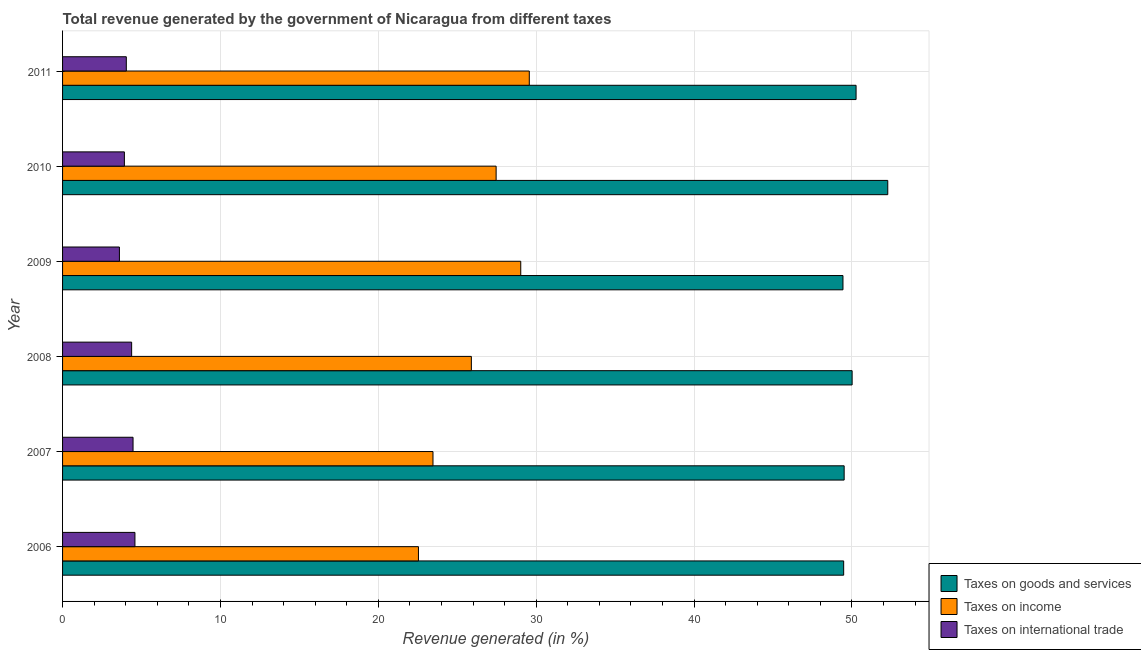How many different coloured bars are there?
Your answer should be very brief. 3. How many groups of bars are there?
Ensure brevity in your answer.  6. Are the number of bars per tick equal to the number of legend labels?
Offer a very short reply. Yes. How many bars are there on the 3rd tick from the top?
Your response must be concise. 3. How many bars are there on the 4th tick from the bottom?
Ensure brevity in your answer.  3. What is the label of the 6th group of bars from the top?
Your answer should be very brief. 2006. In how many cases, is the number of bars for a given year not equal to the number of legend labels?
Give a very brief answer. 0. What is the percentage of revenue generated by taxes on income in 2010?
Keep it short and to the point. 27.46. Across all years, what is the maximum percentage of revenue generated by taxes on goods and services?
Keep it short and to the point. 52.27. Across all years, what is the minimum percentage of revenue generated by taxes on income?
Provide a short and direct response. 22.54. In which year was the percentage of revenue generated by taxes on income maximum?
Offer a terse response. 2011. What is the total percentage of revenue generated by taxes on income in the graph?
Give a very brief answer. 157.94. What is the difference between the percentage of revenue generated by taxes on income in 2008 and that in 2011?
Give a very brief answer. -3.67. What is the difference between the percentage of revenue generated by tax on international trade in 2006 and the percentage of revenue generated by taxes on goods and services in 2008?
Provide a succinct answer. -45.43. What is the average percentage of revenue generated by tax on international trade per year?
Your answer should be very brief. 4.16. In the year 2007, what is the difference between the percentage of revenue generated by taxes on goods and services and percentage of revenue generated by taxes on income?
Provide a short and direct response. 26.04. In how many years, is the percentage of revenue generated by taxes on goods and services greater than 12 %?
Provide a short and direct response. 6. What is the ratio of the percentage of revenue generated by taxes on income in 2008 to that in 2009?
Give a very brief answer. 0.89. What is the difference between the highest and the second highest percentage of revenue generated by tax on international trade?
Keep it short and to the point. 0.12. What is the difference between the highest and the lowest percentage of revenue generated by taxes on income?
Provide a succinct answer. 7.02. In how many years, is the percentage of revenue generated by taxes on income greater than the average percentage of revenue generated by taxes on income taken over all years?
Offer a very short reply. 3. What does the 2nd bar from the top in 2006 represents?
Offer a very short reply. Taxes on income. What does the 1st bar from the bottom in 2009 represents?
Provide a succinct answer. Taxes on goods and services. How many bars are there?
Offer a terse response. 18. Are all the bars in the graph horizontal?
Ensure brevity in your answer.  Yes. Are the values on the major ticks of X-axis written in scientific E-notation?
Keep it short and to the point. No. Does the graph contain any zero values?
Your response must be concise. No. Does the graph contain grids?
Give a very brief answer. Yes. How are the legend labels stacked?
Offer a very short reply. Vertical. What is the title of the graph?
Your answer should be very brief. Total revenue generated by the government of Nicaragua from different taxes. Does "Services" appear as one of the legend labels in the graph?
Provide a short and direct response. No. What is the label or title of the X-axis?
Keep it short and to the point. Revenue generated (in %). What is the label or title of the Y-axis?
Offer a terse response. Year. What is the Revenue generated (in %) in Taxes on goods and services in 2006?
Offer a terse response. 49.47. What is the Revenue generated (in %) in Taxes on income in 2006?
Make the answer very short. 22.54. What is the Revenue generated (in %) in Taxes on international trade in 2006?
Ensure brevity in your answer.  4.58. What is the Revenue generated (in %) in Taxes on goods and services in 2007?
Your answer should be compact. 49.5. What is the Revenue generated (in %) in Taxes on income in 2007?
Give a very brief answer. 23.46. What is the Revenue generated (in %) in Taxes on international trade in 2007?
Make the answer very short. 4.46. What is the Revenue generated (in %) in Taxes on goods and services in 2008?
Provide a short and direct response. 50.01. What is the Revenue generated (in %) of Taxes on income in 2008?
Provide a short and direct response. 25.89. What is the Revenue generated (in %) in Taxes on international trade in 2008?
Your answer should be very brief. 4.38. What is the Revenue generated (in %) of Taxes on goods and services in 2009?
Provide a succinct answer. 49.43. What is the Revenue generated (in %) of Taxes on income in 2009?
Offer a terse response. 29.02. What is the Revenue generated (in %) in Taxes on international trade in 2009?
Your response must be concise. 3.6. What is the Revenue generated (in %) in Taxes on goods and services in 2010?
Offer a terse response. 52.27. What is the Revenue generated (in %) in Taxes on income in 2010?
Provide a short and direct response. 27.46. What is the Revenue generated (in %) in Taxes on international trade in 2010?
Provide a succinct answer. 3.92. What is the Revenue generated (in %) in Taxes on goods and services in 2011?
Offer a terse response. 50.26. What is the Revenue generated (in %) in Taxes on income in 2011?
Offer a very short reply. 29.56. What is the Revenue generated (in %) in Taxes on international trade in 2011?
Offer a very short reply. 4.04. Across all years, what is the maximum Revenue generated (in %) in Taxes on goods and services?
Your response must be concise. 52.27. Across all years, what is the maximum Revenue generated (in %) in Taxes on income?
Make the answer very short. 29.56. Across all years, what is the maximum Revenue generated (in %) in Taxes on international trade?
Your answer should be compact. 4.58. Across all years, what is the minimum Revenue generated (in %) in Taxes on goods and services?
Offer a very short reply. 49.43. Across all years, what is the minimum Revenue generated (in %) in Taxes on income?
Provide a short and direct response. 22.54. Across all years, what is the minimum Revenue generated (in %) in Taxes on international trade?
Keep it short and to the point. 3.6. What is the total Revenue generated (in %) in Taxes on goods and services in the graph?
Provide a succinct answer. 300.95. What is the total Revenue generated (in %) in Taxes on income in the graph?
Offer a very short reply. 157.94. What is the total Revenue generated (in %) in Taxes on international trade in the graph?
Keep it short and to the point. 24.98. What is the difference between the Revenue generated (in %) in Taxes on goods and services in 2006 and that in 2007?
Offer a terse response. -0.03. What is the difference between the Revenue generated (in %) of Taxes on income in 2006 and that in 2007?
Provide a succinct answer. -0.92. What is the difference between the Revenue generated (in %) in Taxes on international trade in 2006 and that in 2007?
Your answer should be very brief. 0.12. What is the difference between the Revenue generated (in %) of Taxes on goods and services in 2006 and that in 2008?
Offer a very short reply. -0.54. What is the difference between the Revenue generated (in %) of Taxes on income in 2006 and that in 2008?
Your response must be concise. -3.35. What is the difference between the Revenue generated (in %) of Taxes on international trade in 2006 and that in 2008?
Offer a terse response. 0.21. What is the difference between the Revenue generated (in %) in Taxes on goods and services in 2006 and that in 2009?
Ensure brevity in your answer.  0.04. What is the difference between the Revenue generated (in %) of Taxes on income in 2006 and that in 2009?
Ensure brevity in your answer.  -6.48. What is the difference between the Revenue generated (in %) in Taxes on international trade in 2006 and that in 2009?
Offer a very short reply. 0.98. What is the difference between the Revenue generated (in %) in Taxes on goods and services in 2006 and that in 2010?
Provide a short and direct response. -2.79. What is the difference between the Revenue generated (in %) in Taxes on income in 2006 and that in 2010?
Keep it short and to the point. -4.92. What is the difference between the Revenue generated (in %) of Taxes on international trade in 2006 and that in 2010?
Your answer should be very brief. 0.67. What is the difference between the Revenue generated (in %) of Taxes on goods and services in 2006 and that in 2011?
Ensure brevity in your answer.  -0.79. What is the difference between the Revenue generated (in %) in Taxes on income in 2006 and that in 2011?
Ensure brevity in your answer.  -7.02. What is the difference between the Revenue generated (in %) of Taxes on international trade in 2006 and that in 2011?
Offer a very short reply. 0.55. What is the difference between the Revenue generated (in %) of Taxes on goods and services in 2007 and that in 2008?
Ensure brevity in your answer.  -0.51. What is the difference between the Revenue generated (in %) of Taxes on income in 2007 and that in 2008?
Your response must be concise. -2.43. What is the difference between the Revenue generated (in %) of Taxes on international trade in 2007 and that in 2008?
Give a very brief answer. 0.09. What is the difference between the Revenue generated (in %) of Taxes on goods and services in 2007 and that in 2009?
Provide a succinct answer. 0.07. What is the difference between the Revenue generated (in %) in Taxes on income in 2007 and that in 2009?
Your response must be concise. -5.56. What is the difference between the Revenue generated (in %) of Taxes on international trade in 2007 and that in 2009?
Keep it short and to the point. 0.86. What is the difference between the Revenue generated (in %) of Taxes on goods and services in 2007 and that in 2010?
Your response must be concise. -2.76. What is the difference between the Revenue generated (in %) in Taxes on income in 2007 and that in 2010?
Your answer should be compact. -4. What is the difference between the Revenue generated (in %) in Taxes on international trade in 2007 and that in 2010?
Keep it short and to the point. 0.55. What is the difference between the Revenue generated (in %) of Taxes on goods and services in 2007 and that in 2011?
Keep it short and to the point. -0.76. What is the difference between the Revenue generated (in %) in Taxes on income in 2007 and that in 2011?
Your response must be concise. -6.1. What is the difference between the Revenue generated (in %) of Taxes on international trade in 2007 and that in 2011?
Your answer should be very brief. 0.43. What is the difference between the Revenue generated (in %) of Taxes on goods and services in 2008 and that in 2009?
Offer a very short reply. 0.58. What is the difference between the Revenue generated (in %) in Taxes on income in 2008 and that in 2009?
Give a very brief answer. -3.13. What is the difference between the Revenue generated (in %) of Taxes on international trade in 2008 and that in 2009?
Your answer should be compact. 0.77. What is the difference between the Revenue generated (in %) in Taxes on goods and services in 2008 and that in 2010?
Your answer should be compact. -2.26. What is the difference between the Revenue generated (in %) in Taxes on income in 2008 and that in 2010?
Your response must be concise. -1.57. What is the difference between the Revenue generated (in %) of Taxes on international trade in 2008 and that in 2010?
Give a very brief answer. 0.46. What is the difference between the Revenue generated (in %) of Taxes on income in 2008 and that in 2011?
Offer a terse response. -3.67. What is the difference between the Revenue generated (in %) of Taxes on international trade in 2008 and that in 2011?
Offer a terse response. 0.34. What is the difference between the Revenue generated (in %) in Taxes on goods and services in 2009 and that in 2010?
Your answer should be compact. -2.84. What is the difference between the Revenue generated (in %) of Taxes on income in 2009 and that in 2010?
Provide a short and direct response. 1.56. What is the difference between the Revenue generated (in %) in Taxes on international trade in 2009 and that in 2010?
Ensure brevity in your answer.  -0.31. What is the difference between the Revenue generated (in %) of Taxes on goods and services in 2009 and that in 2011?
Offer a very short reply. -0.83. What is the difference between the Revenue generated (in %) in Taxes on income in 2009 and that in 2011?
Provide a short and direct response. -0.54. What is the difference between the Revenue generated (in %) of Taxes on international trade in 2009 and that in 2011?
Your answer should be compact. -0.44. What is the difference between the Revenue generated (in %) in Taxes on goods and services in 2010 and that in 2011?
Provide a short and direct response. 2.01. What is the difference between the Revenue generated (in %) in Taxes on income in 2010 and that in 2011?
Your response must be concise. -2.1. What is the difference between the Revenue generated (in %) in Taxes on international trade in 2010 and that in 2011?
Offer a very short reply. -0.12. What is the difference between the Revenue generated (in %) of Taxes on goods and services in 2006 and the Revenue generated (in %) of Taxes on income in 2007?
Provide a short and direct response. 26.01. What is the difference between the Revenue generated (in %) of Taxes on goods and services in 2006 and the Revenue generated (in %) of Taxes on international trade in 2007?
Give a very brief answer. 45.01. What is the difference between the Revenue generated (in %) of Taxes on income in 2006 and the Revenue generated (in %) of Taxes on international trade in 2007?
Your response must be concise. 18.08. What is the difference between the Revenue generated (in %) in Taxes on goods and services in 2006 and the Revenue generated (in %) in Taxes on income in 2008?
Your answer should be very brief. 23.58. What is the difference between the Revenue generated (in %) in Taxes on goods and services in 2006 and the Revenue generated (in %) in Taxes on international trade in 2008?
Provide a short and direct response. 45.1. What is the difference between the Revenue generated (in %) of Taxes on income in 2006 and the Revenue generated (in %) of Taxes on international trade in 2008?
Offer a very short reply. 18.17. What is the difference between the Revenue generated (in %) of Taxes on goods and services in 2006 and the Revenue generated (in %) of Taxes on income in 2009?
Provide a short and direct response. 20.45. What is the difference between the Revenue generated (in %) of Taxes on goods and services in 2006 and the Revenue generated (in %) of Taxes on international trade in 2009?
Your answer should be compact. 45.87. What is the difference between the Revenue generated (in %) in Taxes on income in 2006 and the Revenue generated (in %) in Taxes on international trade in 2009?
Ensure brevity in your answer.  18.94. What is the difference between the Revenue generated (in %) of Taxes on goods and services in 2006 and the Revenue generated (in %) of Taxes on income in 2010?
Offer a very short reply. 22.01. What is the difference between the Revenue generated (in %) in Taxes on goods and services in 2006 and the Revenue generated (in %) in Taxes on international trade in 2010?
Your answer should be very brief. 45.56. What is the difference between the Revenue generated (in %) of Taxes on income in 2006 and the Revenue generated (in %) of Taxes on international trade in 2010?
Your response must be concise. 18.63. What is the difference between the Revenue generated (in %) in Taxes on goods and services in 2006 and the Revenue generated (in %) in Taxes on income in 2011?
Keep it short and to the point. 19.91. What is the difference between the Revenue generated (in %) of Taxes on goods and services in 2006 and the Revenue generated (in %) of Taxes on international trade in 2011?
Give a very brief answer. 45.44. What is the difference between the Revenue generated (in %) in Taxes on income in 2006 and the Revenue generated (in %) in Taxes on international trade in 2011?
Offer a terse response. 18.5. What is the difference between the Revenue generated (in %) of Taxes on goods and services in 2007 and the Revenue generated (in %) of Taxes on income in 2008?
Offer a very short reply. 23.61. What is the difference between the Revenue generated (in %) in Taxes on goods and services in 2007 and the Revenue generated (in %) in Taxes on international trade in 2008?
Give a very brief answer. 45.13. What is the difference between the Revenue generated (in %) in Taxes on income in 2007 and the Revenue generated (in %) in Taxes on international trade in 2008?
Provide a short and direct response. 19.09. What is the difference between the Revenue generated (in %) of Taxes on goods and services in 2007 and the Revenue generated (in %) of Taxes on income in 2009?
Your answer should be very brief. 20.48. What is the difference between the Revenue generated (in %) in Taxes on goods and services in 2007 and the Revenue generated (in %) in Taxes on international trade in 2009?
Give a very brief answer. 45.9. What is the difference between the Revenue generated (in %) in Taxes on income in 2007 and the Revenue generated (in %) in Taxes on international trade in 2009?
Make the answer very short. 19.86. What is the difference between the Revenue generated (in %) of Taxes on goods and services in 2007 and the Revenue generated (in %) of Taxes on income in 2010?
Keep it short and to the point. 22.04. What is the difference between the Revenue generated (in %) of Taxes on goods and services in 2007 and the Revenue generated (in %) of Taxes on international trade in 2010?
Your response must be concise. 45.59. What is the difference between the Revenue generated (in %) in Taxes on income in 2007 and the Revenue generated (in %) in Taxes on international trade in 2010?
Give a very brief answer. 19.55. What is the difference between the Revenue generated (in %) in Taxes on goods and services in 2007 and the Revenue generated (in %) in Taxes on income in 2011?
Keep it short and to the point. 19.94. What is the difference between the Revenue generated (in %) of Taxes on goods and services in 2007 and the Revenue generated (in %) of Taxes on international trade in 2011?
Offer a very short reply. 45.47. What is the difference between the Revenue generated (in %) of Taxes on income in 2007 and the Revenue generated (in %) of Taxes on international trade in 2011?
Provide a succinct answer. 19.42. What is the difference between the Revenue generated (in %) of Taxes on goods and services in 2008 and the Revenue generated (in %) of Taxes on income in 2009?
Make the answer very short. 20.99. What is the difference between the Revenue generated (in %) of Taxes on goods and services in 2008 and the Revenue generated (in %) of Taxes on international trade in 2009?
Keep it short and to the point. 46.41. What is the difference between the Revenue generated (in %) of Taxes on income in 2008 and the Revenue generated (in %) of Taxes on international trade in 2009?
Your answer should be very brief. 22.29. What is the difference between the Revenue generated (in %) of Taxes on goods and services in 2008 and the Revenue generated (in %) of Taxes on income in 2010?
Give a very brief answer. 22.55. What is the difference between the Revenue generated (in %) in Taxes on goods and services in 2008 and the Revenue generated (in %) in Taxes on international trade in 2010?
Make the answer very short. 46.09. What is the difference between the Revenue generated (in %) in Taxes on income in 2008 and the Revenue generated (in %) in Taxes on international trade in 2010?
Keep it short and to the point. 21.98. What is the difference between the Revenue generated (in %) in Taxes on goods and services in 2008 and the Revenue generated (in %) in Taxes on income in 2011?
Ensure brevity in your answer.  20.45. What is the difference between the Revenue generated (in %) of Taxes on goods and services in 2008 and the Revenue generated (in %) of Taxes on international trade in 2011?
Ensure brevity in your answer.  45.97. What is the difference between the Revenue generated (in %) of Taxes on income in 2008 and the Revenue generated (in %) of Taxes on international trade in 2011?
Make the answer very short. 21.86. What is the difference between the Revenue generated (in %) of Taxes on goods and services in 2009 and the Revenue generated (in %) of Taxes on income in 2010?
Your answer should be very brief. 21.97. What is the difference between the Revenue generated (in %) in Taxes on goods and services in 2009 and the Revenue generated (in %) in Taxes on international trade in 2010?
Provide a short and direct response. 45.51. What is the difference between the Revenue generated (in %) of Taxes on income in 2009 and the Revenue generated (in %) of Taxes on international trade in 2010?
Keep it short and to the point. 25.1. What is the difference between the Revenue generated (in %) in Taxes on goods and services in 2009 and the Revenue generated (in %) in Taxes on income in 2011?
Ensure brevity in your answer.  19.87. What is the difference between the Revenue generated (in %) in Taxes on goods and services in 2009 and the Revenue generated (in %) in Taxes on international trade in 2011?
Give a very brief answer. 45.39. What is the difference between the Revenue generated (in %) in Taxes on income in 2009 and the Revenue generated (in %) in Taxes on international trade in 2011?
Your response must be concise. 24.98. What is the difference between the Revenue generated (in %) of Taxes on goods and services in 2010 and the Revenue generated (in %) of Taxes on income in 2011?
Offer a terse response. 22.7. What is the difference between the Revenue generated (in %) in Taxes on goods and services in 2010 and the Revenue generated (in %) in Taxes on international trade in 2011?
Provide a short and direct response. 48.23. What is the difference between the Revenue generated (in %) of Taxes on income in 2010 and the Revenue generated (in %) of Taxes on international trade in 2011?
Offer a very short reply. 23.42. What is the average Revenue generated (in %) of Taxes on goods and services per year?
Provide a short and direct response. 50.16. What is the average Revenue generated (in %) in Taxes on income per year?
Your answer should be very brief. 26.32. What is the average Revenue generated (in %) in Taxes on international trade per year?
Ensure brevity in your answer.  4.16. In the year 2006, what is the difference between the Revenue generated (in %) in Taxes on goods and services and Revenue generated (in %) in Taxes on income?
Ensure brevity in your answer.  26.93. In the year 2006, what is the difference between the Revenue generated (in %) of Taxes on goods and services and Revenue generated (in %) of Taxes on international trade?
Provide a succinct answer. 44.89. In the year 2006, what is the difference between the Revenue generated (in %) in Taxes on income and Revenue generated (in %) in Taxes on international trade?
Your response must be concise. 17.96. In the year 2007, what is the difference between the Revenue generated (in %) of Taxes on goods and services and Revenue generated (in %) of Taxes on income?
Your answer should be compact. 26.04. In the year 2007, what is the difference between the Revenue generated (in %) in Taxes on goods and services and Revenue generated (in %) in Taxes on international trade?
Provide a short and direct response. 45.04. In the year 2007, what is the difference between the Revenue generated (in %) in Taxes on income and Revenue generated (in %) in Taxes on international trade?
Give a very brief answer. 19. In the year 2008, what is the difference between the Revenue generated (in %) of Taxes on goods and services and Revenue generated (in %) of Taxes on income?
Offer a terse response. 24.12. In the year 2008, what is the difference between the Revenue generated (in %) of Taxes on goods and services and Revenue generated (in %) of Taxes on international trade?
Provide a succinct answer. 45.63. In the year 2008, what is the difference between the Revenue generated (in %) of Taxes on income and Revenue generated (in %) of Taxes on international trade?
Make the answer very short. 21.52. In the year 2009, what is the difference between the Revenue generated (in %) of Taxes on goods and services and Revenue generated (in %) of Taxes on income?
Your response must be concise. 20.41. In the year 2009, what is the difference between the Revenue generated (in %) in Taxes on goods and services and Revenue generated (in %) in Taxes on international trade?
Your answer should be compact. 45.83. In the year 2009, what is the difference between the Revenue generated (in %) of Taxes on income and Revenue generated (in %) of Taxes on international trade?
Provide a succinct answer. 25.42. In the year 2010, what is the difference between the Revenue generated (in %) of Taxes on goods and services and Revenue generated (in %) of Taxes on income?
Offer a terse response. 24.81. In the year 2010, what is the difference between the Revenue generated (in %) of Taxes on goods and services and Revenue generated (in %) of Taxes on international trade?
Your answer should be very brief. 48.35. In the year 2010, what is the difference between the Revenue generated (in %) of Taxes on income and Revenue generated (in %) of Taxes on international trade?
Provide a succinct answer. 23.55. In the year 2011, what is the difference between the Revenue generated (in %) of Taxes on goods and services and Revenue generated (in %) of Taxes on income?
Provide a succinct answer. 20.7. In the year 2011, what is the difference between the Revenue generated (in %) of Taxes on goods and services and Revenue generated (in %) of Taxes on international trade?
Your answer should be very brief. 46.22. In the year 2011, what is the difference between the Revenue generated (in %) of Taxes on income and Revenue generated (in %) of Taxes on international trade?
Keep it short and to the point. 25.53. What is the ratio of the Revenue generated (in %) in Taxes on income in 2006 to that in 2007?
Offer a terse response. 0.96. What is the ratio of the Revenue generated (in %) of Taxes on international trade in 2006 to that in 2007?
Give a very brief answer. 1.03. What is the ratio of the Revenue generated (in %) in Taxes on goods and services in 2006 to that in 2008?
Provide a succinct answer. 0.99. What is the ratio of the Revenue generated (in %) in Taxes on income in 2006 to that in 2008?
Your answer should be compact. 0.87. What is the ratio of the Revenue generated (in %) of Taxes on international trade in 2006 to that in 2008?
Your response must be concise. 1.05. What is the ratio of the Revenue generated (in %) of Taxes on income in 2006 to that in 2009?
Offer a very short reply. 0.78. What is the ratio of the Revenue generated (in %) in Taxes on international trade in 2006 to that in 2009?
Offer a terse response. 1.27. What is the ratio of the Revenue generated (in %) of Taxes on goods and services in 2006 to that in 2010?
Provide a succinct answer. 0.95. What is the ratio of the Revenue generated (in %) in Taxes on income in 2006 to that in 2010?
Your response must be concise. 0.82. What is the ratio of the Revenue generated (in %) in Taxes on international trade in 2006 to that in 2010?
Your response must be concise. 1.17. What is the ratio of the Revenue generated (in %) of Taxes on goods and services in 2006 to that in 2011?
Give a very brief answer. 0.98. What is the ratio of the Revenue generated (in %) in Taxes on income in 2006 to that in 2011?
Ensure brevity in your answer.  0.76. What is the ratio of the Revenue generated (in %) of Taxes on international trade in 2006 to that in 2011?
Your answer should be compact. 1.14. What is the ratio of the Revenue generated (in %) in Taxes on goods and services in 2007 to that in 2008?
Provide a short and direct response. 0.99. What is the ratio of the Revenue generated (in %) of Taxes on income in 2007 to that in 2008?
Give a very brief answer. 0.91. What is the ratio of the Revenue generated (in %) of Taxes on international trade in 2007 to that in 2008?
Provide a succinct answer. 1.02. What is the ratio of the Revenue generated (in %) in Taxes on goods and services in 2007 to that in 2009?
Offer a terse response. 1. What is the ratio of the Revenue generated (in %) in Taxes on income in 2007 to that in 2009?
Provide a succinct answer. 0.81. What is the ratio of the Revenue generated (in %) of Taxes on international trade in 2007 to that in 2009?
Ensure brevity in your answer.  1.24. What is the ratio of the Revenue generated (in %) in Taxes on goods and services in 2007 to that in 2010?
Offer a terse response. 0.95. What is the ratio of the Revenue generated (in %) of Taxes on income in 2007 to that in 2010?
Make the answer very short. 0.85. What is the ratio of the Revenue generated (in %) in Taxes on international trade in 2007 to that in 2010?
Offer a terse response. 1.14. What is the ratio of the Revenue generated (in %) of Taxes on income in 2007 to that in 2011?
Ensure brevity in your answer.  0.79. What is the ratio of the Revenue generated (in %) of Taxes on international trade in 2007 to that in 2011?
Your response must be concise. 1.11. What is the ratio of the Revenue generated (in %) in Taxes on goods and services in 2008 to that in 2009?
Offer a very short reply. 1.01. What is the ratio of the Revenue generated (in %) of Taxes on income in 2008 to that in 2009?
Your answer should be very brief. 0.89. What is the ratio of the Revenue generated (in %) of Taxes on international trade in 2008 to that in 2009?
Make the answer very short. 1.21. What is the ratio of the Revenue generated (in %) in Taxes on goods and services in 2008 to that in 2010?
Offer a very short reply. 0.96. What is the ratio of the Revenue generated (in %) in Taxes on income in 2008 to that in 2010?
Your answer should be very brief. 0.94. What is the ratio of the Revenue generated (in %) in Taxes on international trade in 2008 to that in 2010?
Your answer should be very brief. 1.12. What is the ratio of the Revenue generated (in %) in Taxes on income in 2008 to that in 2011?
Your answer should be compact. 0.88. What is the ratio of the Revenue generated (in %) of Taxes on international trade in 2008 to that in 2011?
Offer a very short reply. 1.08. What is the ratio of the Revenue generated (in %) of Taxes on goods and services in 2009 to that in 2010?
Offer a terse response. 0.95. What is the ratio of the Revenue generated (in %) of Taxes on income in 2009 to that in 2010?
Provide a short and direct response. 1.06. What is the ratio of the Revenue generated (in %) in Taxes on international trade in 2009 to that in 2010?
Offer a terse response. 0.92. What is the ratio of the Revenue generated (in %) in Taxes on goods and services in 2009 to that in 2011?
Make the answer very short. 0.98. What is the ratio of the Revenue generated (in %) in Taxes on income in 2009 to that in 2011?
Your response must be concise. 0.98. What is the ratio of the Revenue generated (in %) of Taxes on international trade in 2009 to that in 2011?
Make the answer very short. 0.89. What is the ratio of the Revenue generated (in %) in Taxes on goods and services in 2010 to that in 2011?
Provide a short and direct response. 1.04. What is the ratio of the Revenue generated (in %) in Taxes on income in 2010 to that in 2011?
Provide a succinct answer. 0.93. What is the ratio of the Revenue generated (in %) of Taxes on international trade in 2010 to that in 2011?
Offer a terse response. 0.97. What is the difference between the highest and the second highest Revenue generated (in %) in Taxes on goods and services?
Make the answer very short. 2.01. What is the difference between the highest and the second highest Revenue generated (in %) in Taxes on income?
Keep it short and to the point. 0.54. What is the difference between the highest and the second highest Revenue generated (in %) in Taxes on international trade?
Your response must be concise. 0.12. What is the difference between the highest and the lowest Revenue generated (in %) of Taxes on goods and services?
Offer a very short reply. 2.84. What is the difference between the highest and the lowest Revenue generated (in %) in Taxes on income?
Give a very brief answer. 7.02. What is the difference between the highest and the lowest Revenue generated (in %) of Taxes on international trade?
Provide a short and direct response. 0.98. 